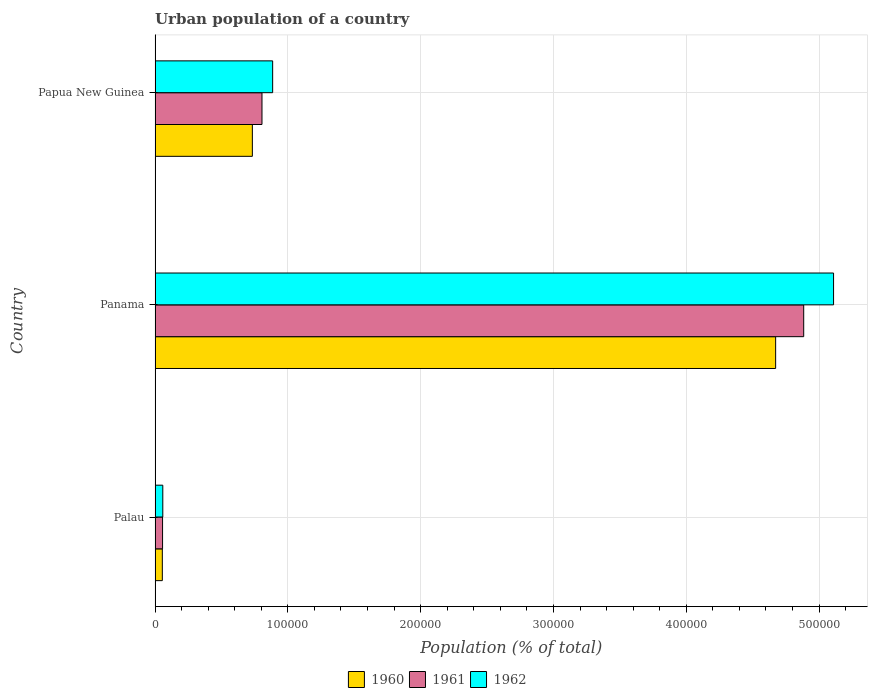Are the number of bars on each tick of the Y-axis equal?
Your answer should be very brief. Yes. How many bars are there on the 2nd tick from the top?
Give a very brief answer. 3. How many bars are there on the 1st tick from the bottom?
Your answer should be compact. 3. What is the label of the 1st group of bars from the top?
Ensure brevity in your answer.  Papua New Guinea. What is the urban population in 1961 in Palau?
Provide a short and direct response. 5655. Across all countries, what is the maximum urban population in 1962?
Offer a very short reply. 5.11e+05. Across all countries, what is the minimum urban population in 1962?
Offer a terse response. 5827. In which country was the urban population in 1961 maximum?
Provide a succinct answer. Panama. In which country was the urban population in 1960 minimum?
Offer a terse response. Palau. What is the total urban population in 1960 in the graph?
Keep it short and to the point. 5.46e+05. What is the difference between the urban population in 1960 in Palau and that in Panama?
Ensure brevity in your answer.  -4.62e+05. What is the difference between the urban population in 1961 in Panama and the urban population in 1962 in Papua New Guinea?
Provide a succinct answer. 4.00e+05. What is the average urban population in 1960 per country?
Offer a terse response. 1.82e+05. What is the difference between the urban population in 1960 and urban population in 1962 in Papua New Guinea?
Make the answer very short. -1.53e+04. In how many countries, is the urban population in 1960 greater than 280000 %?
Ensure brevity in your answer.  1. What is the ratio of the urban population in 1961 in Palau to that in Panama?
Give a very brief answer. 0.01. Is the difference between the urban population in 1960 in Panama and Papua New Guinea greater than the difference between the urban population in 1962 in Panama and Papua New Guinea?
Ensure brevity in your answer.  No. What is the difference between the highest and the second highest urban population in 1962?
Offer a very short reply. 4.22e+05. What is the difference between the highest and the lowest urban population in 1960?
Your answer should be very brief. 4.62e+05. In how many countries, is the urban population in 1961 greater than the average urban population in 1961 taken over all countries?
Offer a terse response. 1. Is the sum of the urban population in 1962 in Palau and Papua New Guinea greater than the maximum urban population in 1961 across all countries?
Give a very brief answer. No. What does the 3rd bar from the top in Panama represents?
Your answer should be compact. 1960. Is it the case that in every country, the sum of the urban population in 1960 and urban population in 1961 is greater than the urban population in 1962?
Offer a very short reply. Yes. Are all the bars in the graph horizontal?
Make the answer very short. Yes. What is the difference between two consecutive major ticks on the X-axis?
Provide a short and direct response. 1.00e+05. Are the values on the major ticks of X-axis written in scientific E-notation?
Keep it short and to the point. No. Does the graph contain any zero values?
Offer a very short reply. No. Does the graph contain grids?
Make the answer very short. Yes. Where does the legend appear in the graph?
Offer a very short reply. Bottom center. How many legend labels are there?
Make the answer very short. 3. What is the title of the graph?
Ensure brevity in your answer.  Urban population of a country. What is the label or title of the X-axis?
Offer a terse response. Population (% of total). What is the label or title of the Y-axis?
Provide a succinct answer. Country. What is the Population (% of total) in 1960 in Palau?
Your answer should be very brief. 5477. What is the Population (% of total) of 1961 in Palau?
Give a very brief answer. 5655. What is the Population (% of total) of 1962 in Palau?
Your answer should be very brief. 5827. What is the Population (% of total) in 1960 in Panama?
Give a very brief answer. 4.67e+05. What is the Population (% of total) of 1961 in Panama?
Provide a succinct answer. 4.88e+05. What is the Population (% of total) of 1962 in Panama?
Offer a terse response. 5.11e+05. What is the Population (% of total) in 1960 in Papua New Guinea?
Keep it short and to the point. 7.33e+04. What is the Population (% of total) in 1961 in Papua New Guinea?
Your answer should be very brief. 8.05e+04. What is the Population (% of total) of 1962 in Papua New Guinea?
Keep it short and to the point. 8.86e+04. Across all countries, what is the maximum Population (% of total) in 1960?
Offer a very short reply. 4.67e+05. Across all countries, what is the maximum Population (% of total) of 1961?
Ensure brevity in your answer.  4.88e+05. Across all countries, what is the maximum Population (% of total) of 1962?
Provide a short and direct response. 5.11e+05. Across all countries, what is the minimum Population (% of total) of 1960?
Offer a terse response. 5477. Across all countries, what is the minimum Population (% of total) of 1961?
Provide a short and direct response. 5655. Across all countries, what is the minimum Population (% of total) in 1962?
Your answer should be compact. 5827. What is the total Population (% of total) in 1960 in the graph?
Keep it short and to the point. 5.46e+05. What is the total Population (% of total) in 1961 in the graph?
Give a very brief answer. 5.75e+05. What is the total Population (% of total) in 1962 in the graph?
Make the answer very short. 6.05e+05. What is the difference between the Population (% of total) of 1960 in Palau and that in Panama?
Offer a terse response. -4.62e+05. What is the difference between the Population (% of total) of 1961 in Palau and that in Panama?
Your answer should be very brief. -4.83e+05. What is the difference between the Population (% of total) of 1962 in Palau and that in Panama?
Your answer should be compact. -5.05e+05. What is the difference between the Population (% of total) of 1960 in Palau and that in Papua New Guinea?
Provide a succinct answer. -6.78e+04. What is the difference between the Population (% of total) of 1961 in Palau and that in Papua New Guinea?
Provide a short and direct response. -7.49e+04. What is the difference between the Population (% of total) in 1962 in Palau and that in Papua New Guinea?
Your response must be concise. -8.27e+04. What is the difference between the Population (% of total) in 1960 in Panama and that in Papua New Guinea?
Provide a short and direct response. 3.94e+05. What is the difference between the Population (% of total) in 1961 in Panama and that in Papua New Guinea?
Provide a short and direct response. 4.08e+05. What is the difference between the Population (% of total) of 1962 in Panama and that in Papua New Guinea?
Your response must be concise. 4.22e+05. What is the difference between the Population (% of total) in 1960 in Palau and the Population (% of total) in 1961 in Panama?
Offer a terse response. -4.83e+05. What is the difference between the Population (% of total) in 1960 in Palau and the Population (% of total) in 1962 in Panama?
Make the answer very short. -5.05e+05. What is the difference between the Population (% of total) in 1961 in Palau and the Population (% of total) in 1962 in Panama?
Offer a terse response. -5.05e+05. What is the difference between the Population (% of total) of 1960 in Palau and the Population (% of total) of 1961 in Papua New Guinea?
Make the answer very short. -7.50e+04. What is the difference between the Population (% of total) of 1960 in Palau and the Population (% of total) of 1962 in Papua New Guinea?
Give a very brief answer. -8.31e+04. What is the difference between the Population (% of total) of 1961 in Palau and the Population (% of total) of 1962 in Papua New Guinea?
Offer a very short reply. -8.29e+04. What is the difference between the Population (% of total) in 1960 in Panama and the Population (% of total) in 1961 in Papua New Guinea?
Ensure brevity in your answer.  3.87e+05. What is the difference between the Population (% of total) in 1960 in Panama and the Population (% of total) in 1962 in Papua New Guinea?
Provide a succinct answer. 3.79e+05. What is the difference between the Population (% of total) in 1961 in Panama and the Population (% of total) in 1962 in Papua New Guinea?
Offer a terse response. 4.00e+05. What is the average Population (% of total) of 1960 per country?
Give a very brief answer. 1.82e+05. What is the average Population (% of total) of 1961 per country?
Your response must be concise. 1.92e+05. What is the average Population (% of total) of 1962 per country?
Provide a succinct answer. 2.02e+05. What is the difference between the Population (% of total) in 1960 and Population (% of total) in 1961 in Palau?
Make the answer very short. -178. What is the difference between the Population (% of total) in 1960 and Population (% of total) in 1962 in Palau?
Your answer should be compact. -350. What is the difference between the Population (% of total) in 1961 and Population (% of total) in 1962 in Palau?
Provide a short and direct response. -172. What is the difference between the Population (% of total) in 1960 and Population (% of total) in 1961 in Panama?
Give a very brief answer. -2.11e+04. What is the difference between the Population (% of total) of 1960 and Population (% of total) of 1962 in Panama?
Provide a succinct answer. -4.36e+04. What is the difference between the Population (% of total) of 1961 and Population (% of total) of 1962 in Panama?
Provide a short and direct response. -2.25e+04. What is the difference between the Population (% of total) of 1960 and Population (% of total) of 1961 in Papua New Guinea?
Your answer should be very brief. -7253. What is the difference between the Population (% of total) of 1960 and Population (% of total) of 1962 in Papua New Guinea?
Provide a succinct answer. -1.53e+04. What is the difference between the Population (% of total) of 1961 and Population (% of total) of 1962 in Papua New Guinea?
Give a very brief answer. -8034. What is the ratio of the Population (% of total) of 1960 in Palau to that in Panama?
Your answer should be compact. 0.01. What is the ratio of the Population (% of total) of 1961 in Palau to that in Panama?
Your response must be concise. 0.01. What is the ratio of the Population (% of total) in 1962 in Palau to that in Panama?
Offer a very short reply. 0.01. What is the ratio of the Population (% of total) of 1960 in Palau to that in Papua New Guinea?
Your response must be concise. 0.07. What is the ratio of the Population (% of total) of 1961 in Palau to that in Papua New Guinea?
Ensure brevity in your answer.  0.07. What is the ratio of the Population (% of total) of 1962 in Palau to that in Papua New Guinea?
Ensure brevity in your answer.  0.07. What is the ratio of the Population (% of total) of 1960 in Panama to that in Papua New Guinea?
Your answer should be compact. 6.38. What is the ratio of the Population (% of total) in 1961 in Panama to that in Papua New Guinea?
Make the answer very short. 6.07. What is the ratio of the Population (% of total) of 1962 in Panama to that in Papua New Guinea?
Make the answer very short. 5.77. What is the difference between the highest and the second highest Population (% of total) of 1960?
Your answer should be very brief. 3.94e+05. What is the difference between the highest and the second highest Population (% of total) of 1961?
Your response must be concise. 4.08e+05. What is the difference between the highest and the second highest Population (% of total) in 1962?
Provide a succinct answer. 4.22e+05. What is the difference between the highest and the lowest Population (% of total) in 1960?
Your answer should be compact. 4.62e+05. What is the difference between the highest and the lowest Population (% of total) in 1961?
Give a very brief answer. 4.83e+05. What is the difference between the highest and the lowest Population (% of total) of 1962?
Offer a terse response. 5.05e+05. 